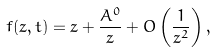<formula> <loc_0><loc_0><loc_500><loc_500>f ( z , t ) = z + \frac { A ^ { 0 } } { z } + O \left ( \frac { 1 } { z ^ { 2 } } \right ) ,</formula> 